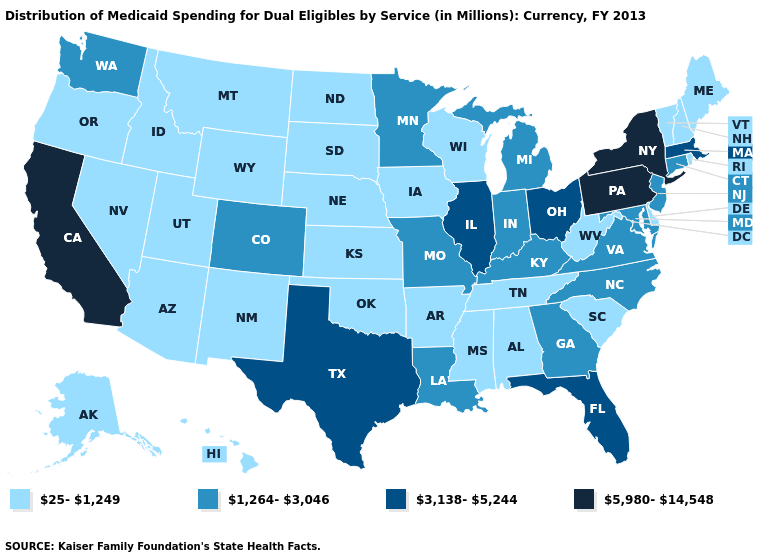Does Florida have the highest value in the USA?
Short answer required. No. Which states hav the highest value in the West?
Short answer required. California. What is the highest value in states that border Vermont?
Answer briefly. 5,980-14,548. What is the value of South Dakota?
Answer briefly. 25-1,249. What is the lowest value in the USA?
Concise answer only. 25-1,249. How many symbols are there in the legend?
Write a very short answer. 4. What is the value of Oklahoma?
Concise answer only. 25-1,249. What is the lowest value in the West?
Keep it brief. 25-1,249. What is the value of California?
Write a very short answer. 5,980-14,548. Does the first symbol in the legend represent the smallest category?
Give a very brief answer. Yes. Does New Mexico have a lower value than Hawaii?
Quick response, please. No. Does the first symbol in the legend represent the smallest category?
Short answer required. Yes. Which states have the lowest value in the MidWest?
Concise answer only. Iowa, Kansas, Nebraska, North Dakota, South Dakota, Wisconsin. Among the states that border New Jersey , which have the highest value?
Quick response, please. New York, Pennsylvania. Among the states that border Utah , does New Mexico have the lowest value?
Short answer required. Yes. 